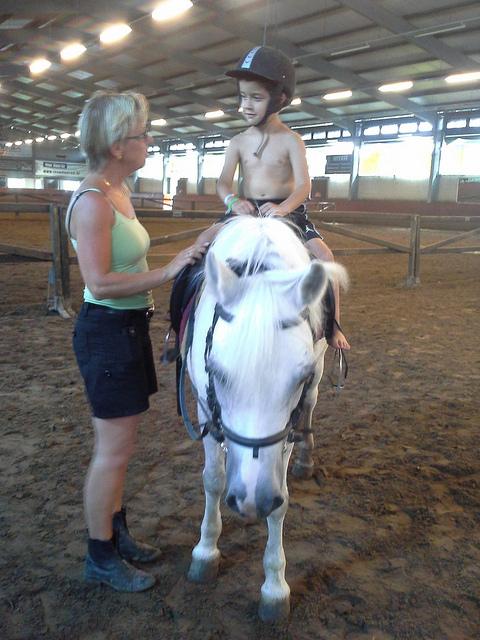What does the horse look like?
Write a very short answer. White. Is this a competition?
Answer briefly. No. What is the color of the horse?
Give a very brief answer. White. Does the child have a shirt on?
Be succinct. No. What is the child riding?
Write a very short answer. Horse. 